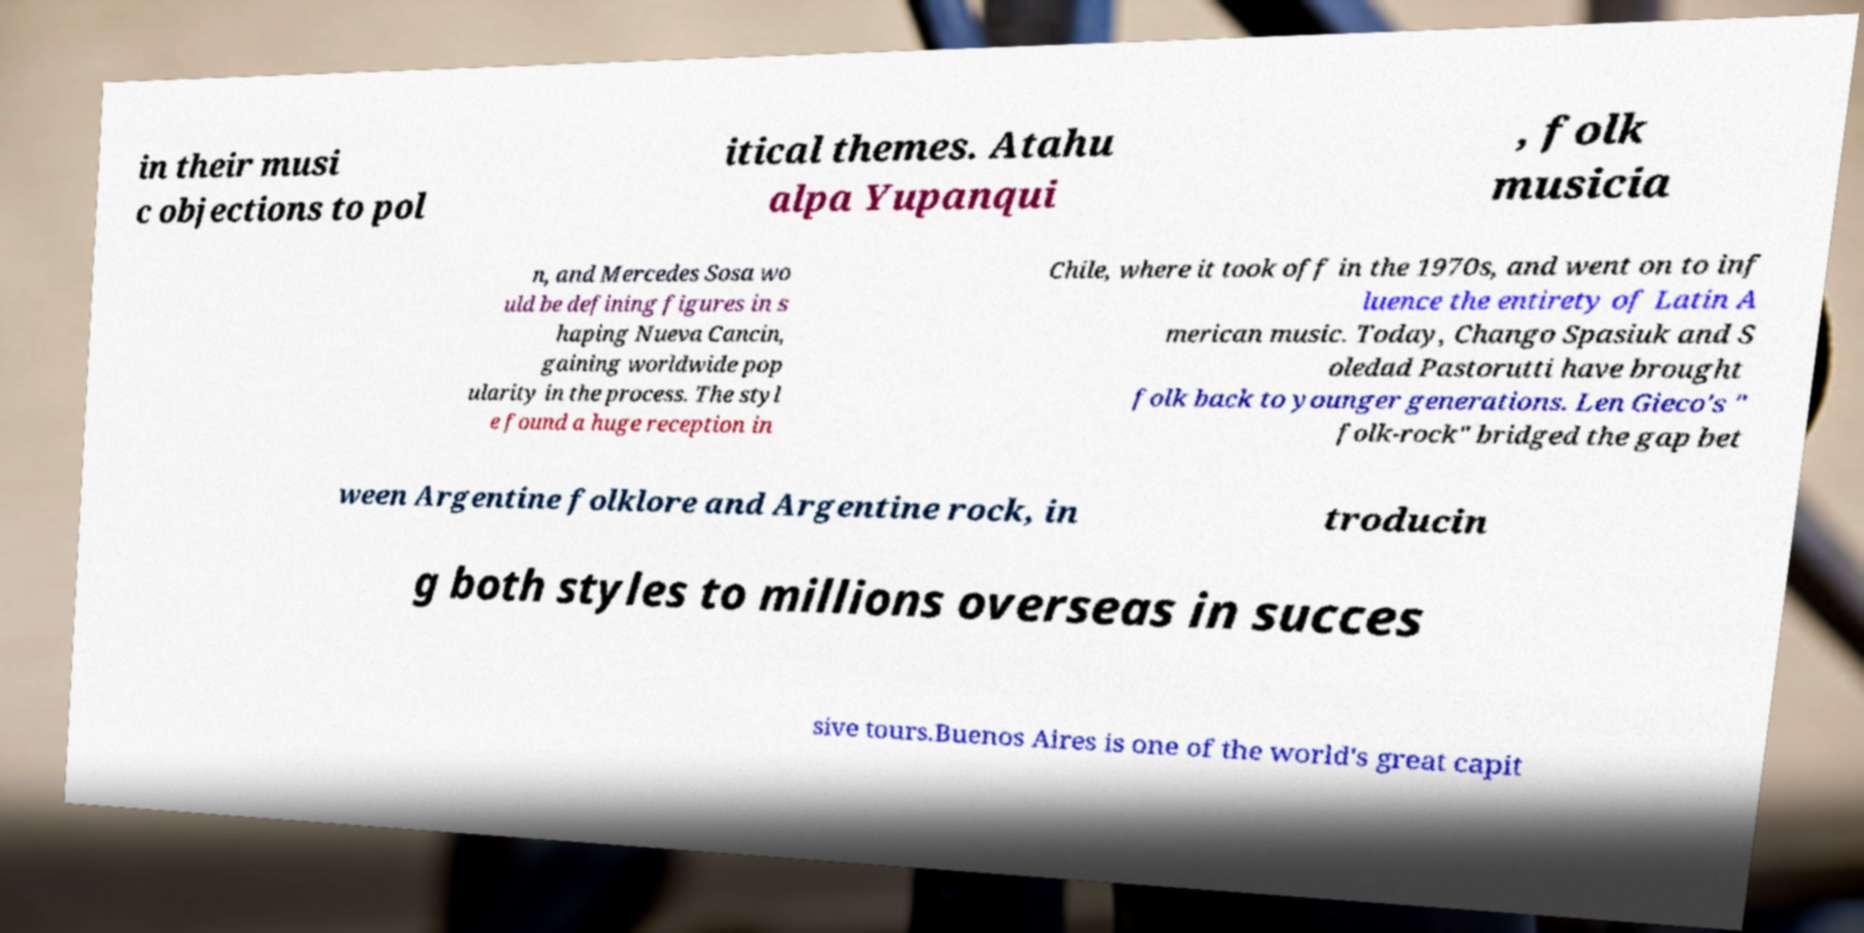What messages or text are displayed in this image? I need them in a readable, typed format. in their musi c objections to pol itical themes. Atahu alpa Yupanqui , folk musicia n, and Mercedes Sosa wo uld be defining figures in s haping Nueva Cancin, gaining worldwide pop ularity in the process. The styl e found a huge reception in Chile, where it took off in the 1970s, and went on to inf luence the entirety of Latin A merican music. Today, Chango Spasiuk and S oledad Pastorutti have brought folk back to younger generations. Len Gieco's " folk-rock" bridged the gap bet ween Argentine folklore and Argentine rock, in troducin g both styles to millions overseas in succes sive tours.Buenos Aires is one of the world's great capit 